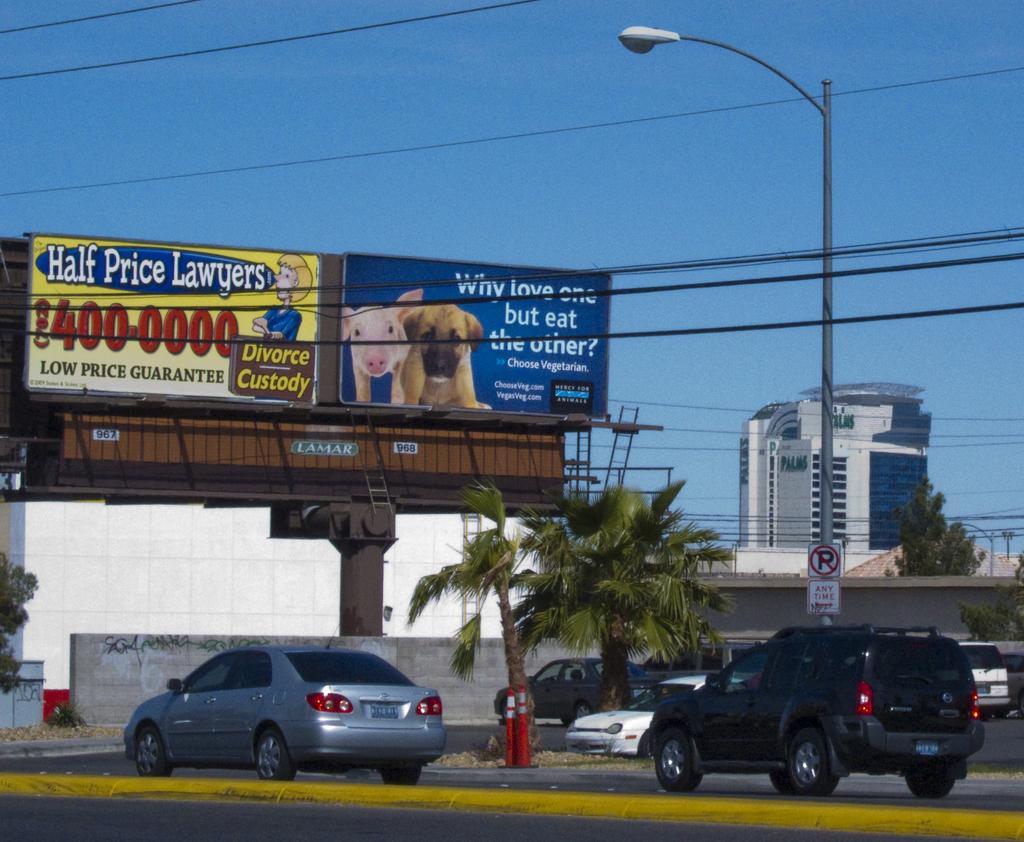Describe this image in one or two sentences. In this image I see hoardings on which there are words and numbers written on it and I see a picture of a pig and a dog over here and I see buildings, a light pole, wires, trees and I see cars on the road and I see the blue sky in the background. 